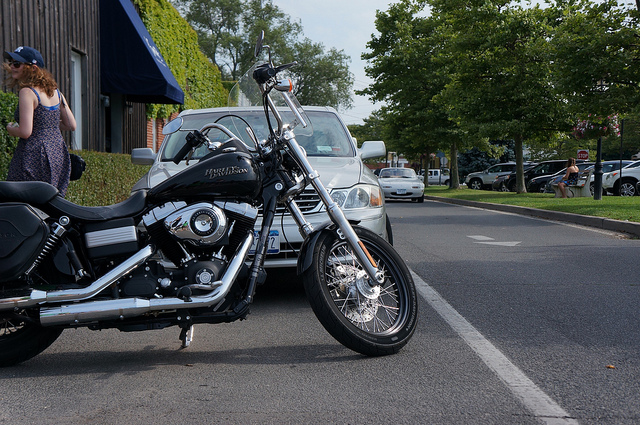<image>What kind of hat is the girl wearing? The girl might not be wearing a hat, but if she is, it could be a baseball cap. What kind of hat is the girl wearing? There is no hat on the girl in the image. 